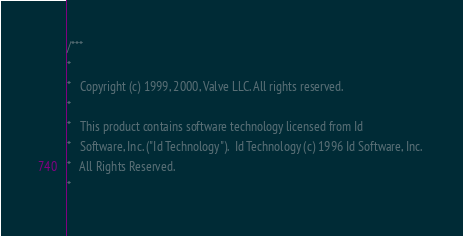<code> <loc_0><loc_0><loc_500><loc_500><_C_>/***
*
*	Copyright (c) 1999, 2000, Valve LLC. All rights reserved.
*	
*	This product contains software technology licensed from Id 
*	Software, Inc. ("Id Technology").  Id Technology (c) 1996 Id Software, Inc. 
*	All Rights Reserved.
*</code> 